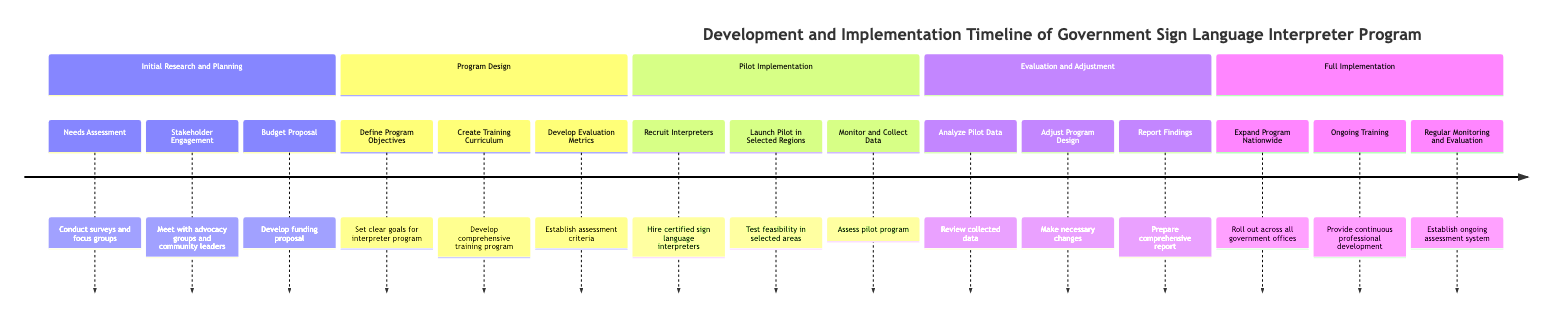What is the duration of the Program Design phase? The Program Design phase is listed in the diagram with a specified duration of 2 months. This value is clearly stated in the section header for Program Design.
Answer: 2 months Who is responsible for the Evaluation and Adjustment phase? The diagram indicates that the Independent Evaluation Committee is responsible for overseeing the Evaluation and Adjustment phase as noted in the responsible entity for that section.
Answer: Independent Evaluation Committee How many activities are listed under Full Implementation? In the Full Implementation section, there are three distinct activities noted: Expand Program Nationwide, Ongoing Training, and Regular Monitoring and Evaluation, meaning there are three activities total.
Answer: 3 What task involves launching the interpreter program in selected regions? The task listed under the Pilot Implementation phase for launching the program in selected regions is titled "Launch Pilot in Selected Regions". This phrase is clearly captured in the activities related to that phase.
Answer: Launch Pilot in Selected Regions What is the first task in the Initial Research and Planning phase? The first task enumerated in the Initial Research and Planning phase is "Needs Assessment". This is seen at the top of the list of activities within that section.
Answer: Needs Assessment Which phase includes establishing criteria for assessing the effectiveness of interpreter services? The phase that includes establishing criteria for assessing the effectiveness of interpreter services is Program Design. Specifically, the task "Develop Evaluation Metrics" is stated in that section.
Answer: Program Design What is the duration of the Pilot Implementation phase? The Pilot Implementation phase is explicitly mentioned to last for a duration of 6 months as indicated in the section header of that phase.
Answer: 6 months Which department is responsible for the Budget Proposal task? The Budget Proposal task is within the Initial Research and Planning phase, and the responsible entity for this task is the Department of Social Services, as mentioned in the diagram.
Answer: Department of Social Services 